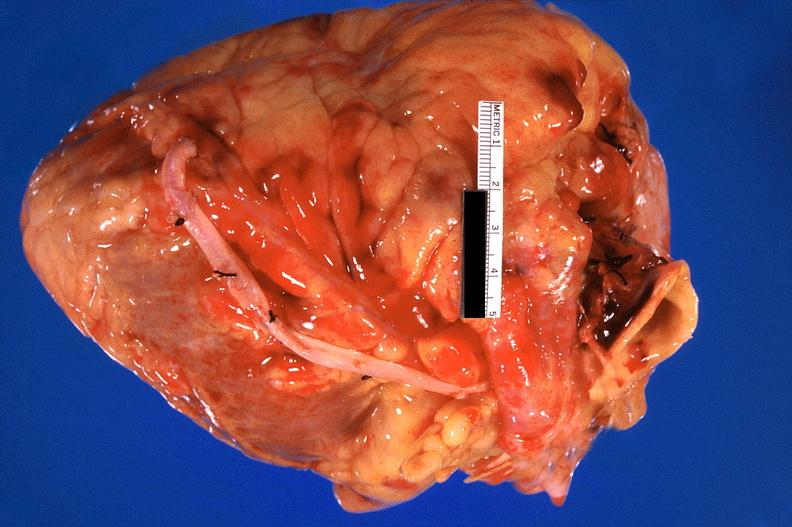does this image show heart, recent coronary artery bypass graft?
Answer the question using a single word or phrase. Yes 